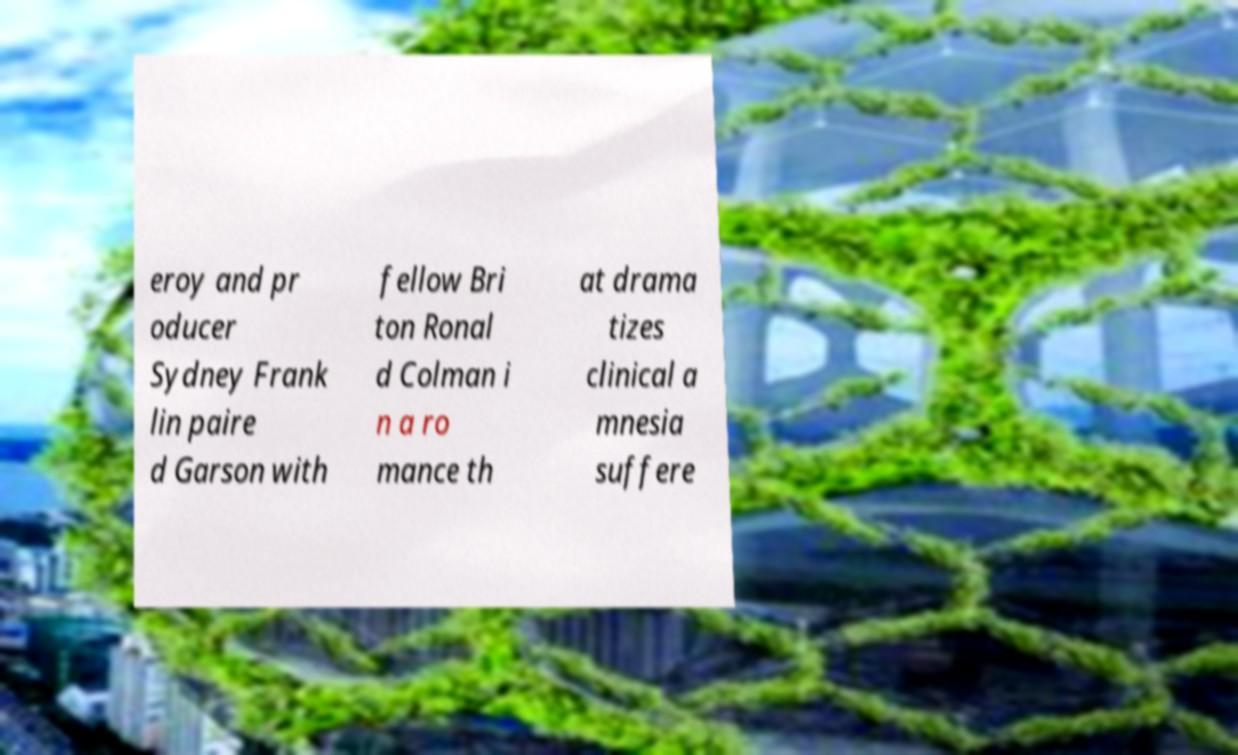Please identify and transcribe the text found in this image. eroy and pr oducer Sydney Frank lin paire d Garson with fellow Bri ton Ronal d Colman i n a ro mance th at drama tizes clinical a mnesia suffere 